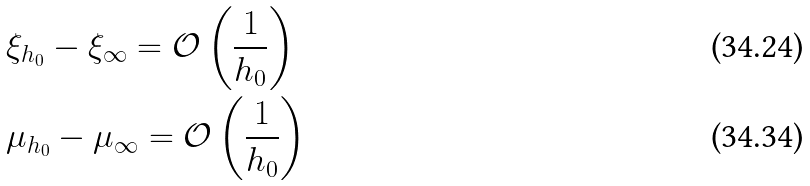Convert formula to latex. <formula><loc_0><loc_0><loc_500><loc_500>& \xi _ { h _ { 0 } } - \xi _ { \infty } = \mathcal { O } \left ( \frac { 1 } { h _ { 0 } } \right ) \\ & \mu _ { h _ { 0 } } - \mu _ { \infty } = \mathcal { O } \left ( \frac { 1 } { h _ { 0 } } \right )</formula> 